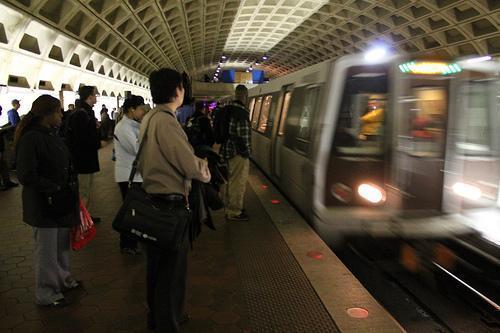How many subway trains are there?
Give a very brief answer. 1. 